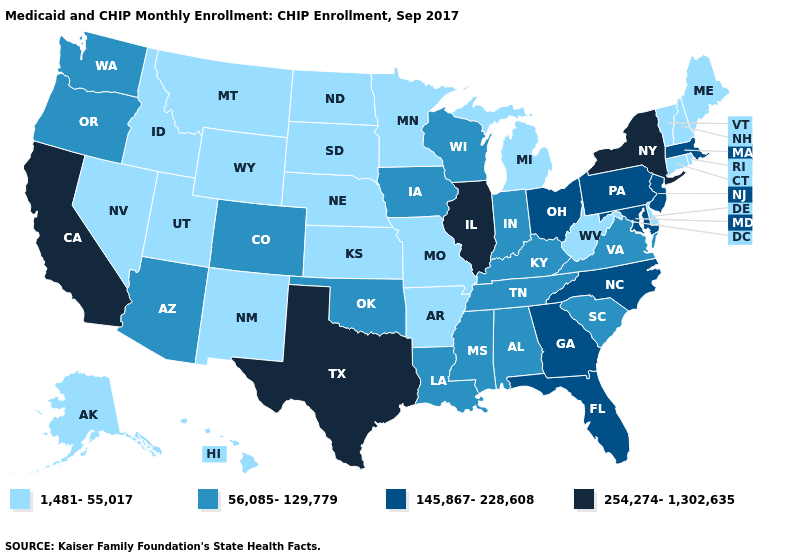Name the states that have a value in the range 1,481-55,017?
Quick response, please. Alaska, Arkansas, Connecticut, Delaware, Hawaii, Idaho, Kansas, Maine, Michigan, Minnesota, Missouri, Montana, Nebraska, Nevada, New Hampshire, New Mexico, North Dakota, Rhode Island, South Dakota, Utah, Vermont, West Virginia, Wyoming. What is the value of Nevada?
Give a very brief answer. 1,481-55,017. Which states have the lowest value in the West?
Answer briefly. Alaska, Hawaii, Idaho, Montana, Nevada, New Mexico, Utah, Wyoming. Name the states that have a value in the range 56,085-129,779?
Give a very brief answer. Alabama, Arizona, Colorado, Indiana, Iowa, Kentucky, Louisiana, Mississippi, Oklahoma, Oregon, South Carolina, Tennessee, Virginia, Washington, Wisconsin. What is the lowest value in the USA?
Quick response, please. 1,481-55,017. What is the lowest value in the USA?
Give a very brief answer. 1,481-55,017. Name the states that have a value in the range 56,085-129,779?
Answer briefly. Alabama, Arizona, Colorado, Indiana, Iowa, Kentucky, Louisiana, Mississippi, Oklahoma, Oregon, South Carolina, Tennessee, Virginia, Washington, Wisconsin. Does Arkansas have a higher value than Wisconsin?
Write a very short answer. No. What is the highest value in the USA?
Be succinct. 254,274-1,302,635. Among the states that border Oregon , does California have the lowest value?
Concise answer only. No. What is the value of Georgia?
Keep it brief. 145,867-228,608. Does the map have missing data?
Write a very short answer. No. Among the states that border Delaware , which have the lowest value?
Write a very short answer. Maryland, New Jersey, Pennsylvania. Does California have the highest value in the West?
Answer briefly. Yes. What is the highest value in the USA?
Write a very short answer. 254,274-1,302,635. 